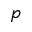Convert formula to latex. <formula><loc_0><loc_0><loc_500><loc_500>p</formula> 